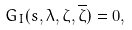<formula> <loc_0><loc_0><loc_500><loc_500>G _ { I } ( s , \lambda , \zeta , \overline { \zeta } ) = 0 ,</formula> 